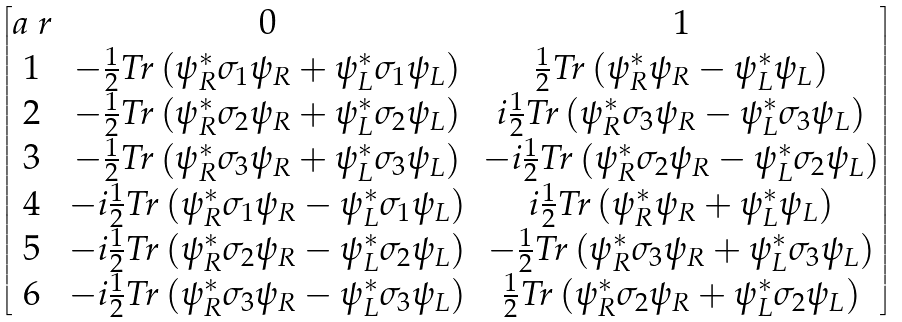Convert formula to latex. <formula><loc_0><loc_0><loc_500><loc_500>\begin{bmatrix} a \ r & 0 & 1 \\ 1 & - \frac { 1 } { 2 } T r \left ( \psi _ { R } ^ { \ast } \sigma _ { 1 } \psi _ { R } + \psi _ { L } ^ { \ast } \sigma _ { 1 } \psi _ { L } \right ) & \frac { 1 } { 2 } T r \left ( \psi _ { R } ^ { \ast } \psi _ { R } - \psi _ { L } ^ { \ast } \psi _ { L } \right ) \\ 2 & - \frac { 1 } { 2 } T r \left ( \psi _ { R } ^ { \ast } \sigma _ { 2 } \psi _ { R } + \psi _ { L } ^ { \ast } \sigma _ { 2 } \psi _ { L } \right ) & i \frac { 1 } { 2 } T r \left ( \psi _ { R } ^ { \ast } \sigma _ { 3 } \psi _ { R } - \psi _ { L } ^ { \ast } \sigma _ { 3 } \psi _ { L } \right ) \\ 3 & - \frac { 1 } { 2 } T r \left ( \psi _ { R } ^ { \ast } \sigma _ { 3 } \psi _ { R } + \psi _ { L } ^ { \ast } \sigma _ { 3 } \psi _ { L } \right ) & - i \frac { 1 } { 2 } T r \left ( \psi _ { R } ^ { \ast } \sigma _ { 2 } \psi _ { R } - \psi _ { L } ^ { \ast } \sigma _ { 2 } \psi _ { L } \right ) \\ 4 & - i \frac { 1 } { 2 } T r \left ( \psi _ { R } ^ { \ast } \sigma _ { 1 } \psi _ { R } - \psi _ { L } ^ { \ast } \sigma _ { 1 } \psi _ { L } \right ) & i \frac { 1 } { 2 } T r \left ( \psi _ { R } ^ { \ast } \psi _ { R } + \psi _ { L } ^ { \ast } \psi _ { L } \right ) \\ 5 & - i \frac { 1 } { 2 } T r \left ( \psi _ { R } ^ { \ast } \sigma _ { 2 } \psi _ { R } - \psi _ { L } ^ { \ast } \sigma _ { 2 } \psi _ { L } \right ) & - \frac { 1 } { 2 } T r \left ( \psi _ { R } ^ { \ast } \sigma _ { 3 } \psi _ { R } + \psi _ { L } ^ { \ast } \sigma _ { 3 } \psi _ { L } \right ) \\ 6 & - i \frac { 1 } { 2 } T r \left ( \psi _ { R } ^ { \ast } \sigma _ { 3 } \psi _ { R } - \psi _ { L } ^ { \ast } \sigma _ { 3 } \psi _ { L } \right ) & \frac { 1 } { 2 } T r \left ( \psi _ { R } ^ { \ast } \sigma _ { 2 } \psi _ { R } + \psi _ { L } ^ { \ast } \sigma _ { 2 } \psi _ { L } \right ) \end{bmatrix}</formula> 